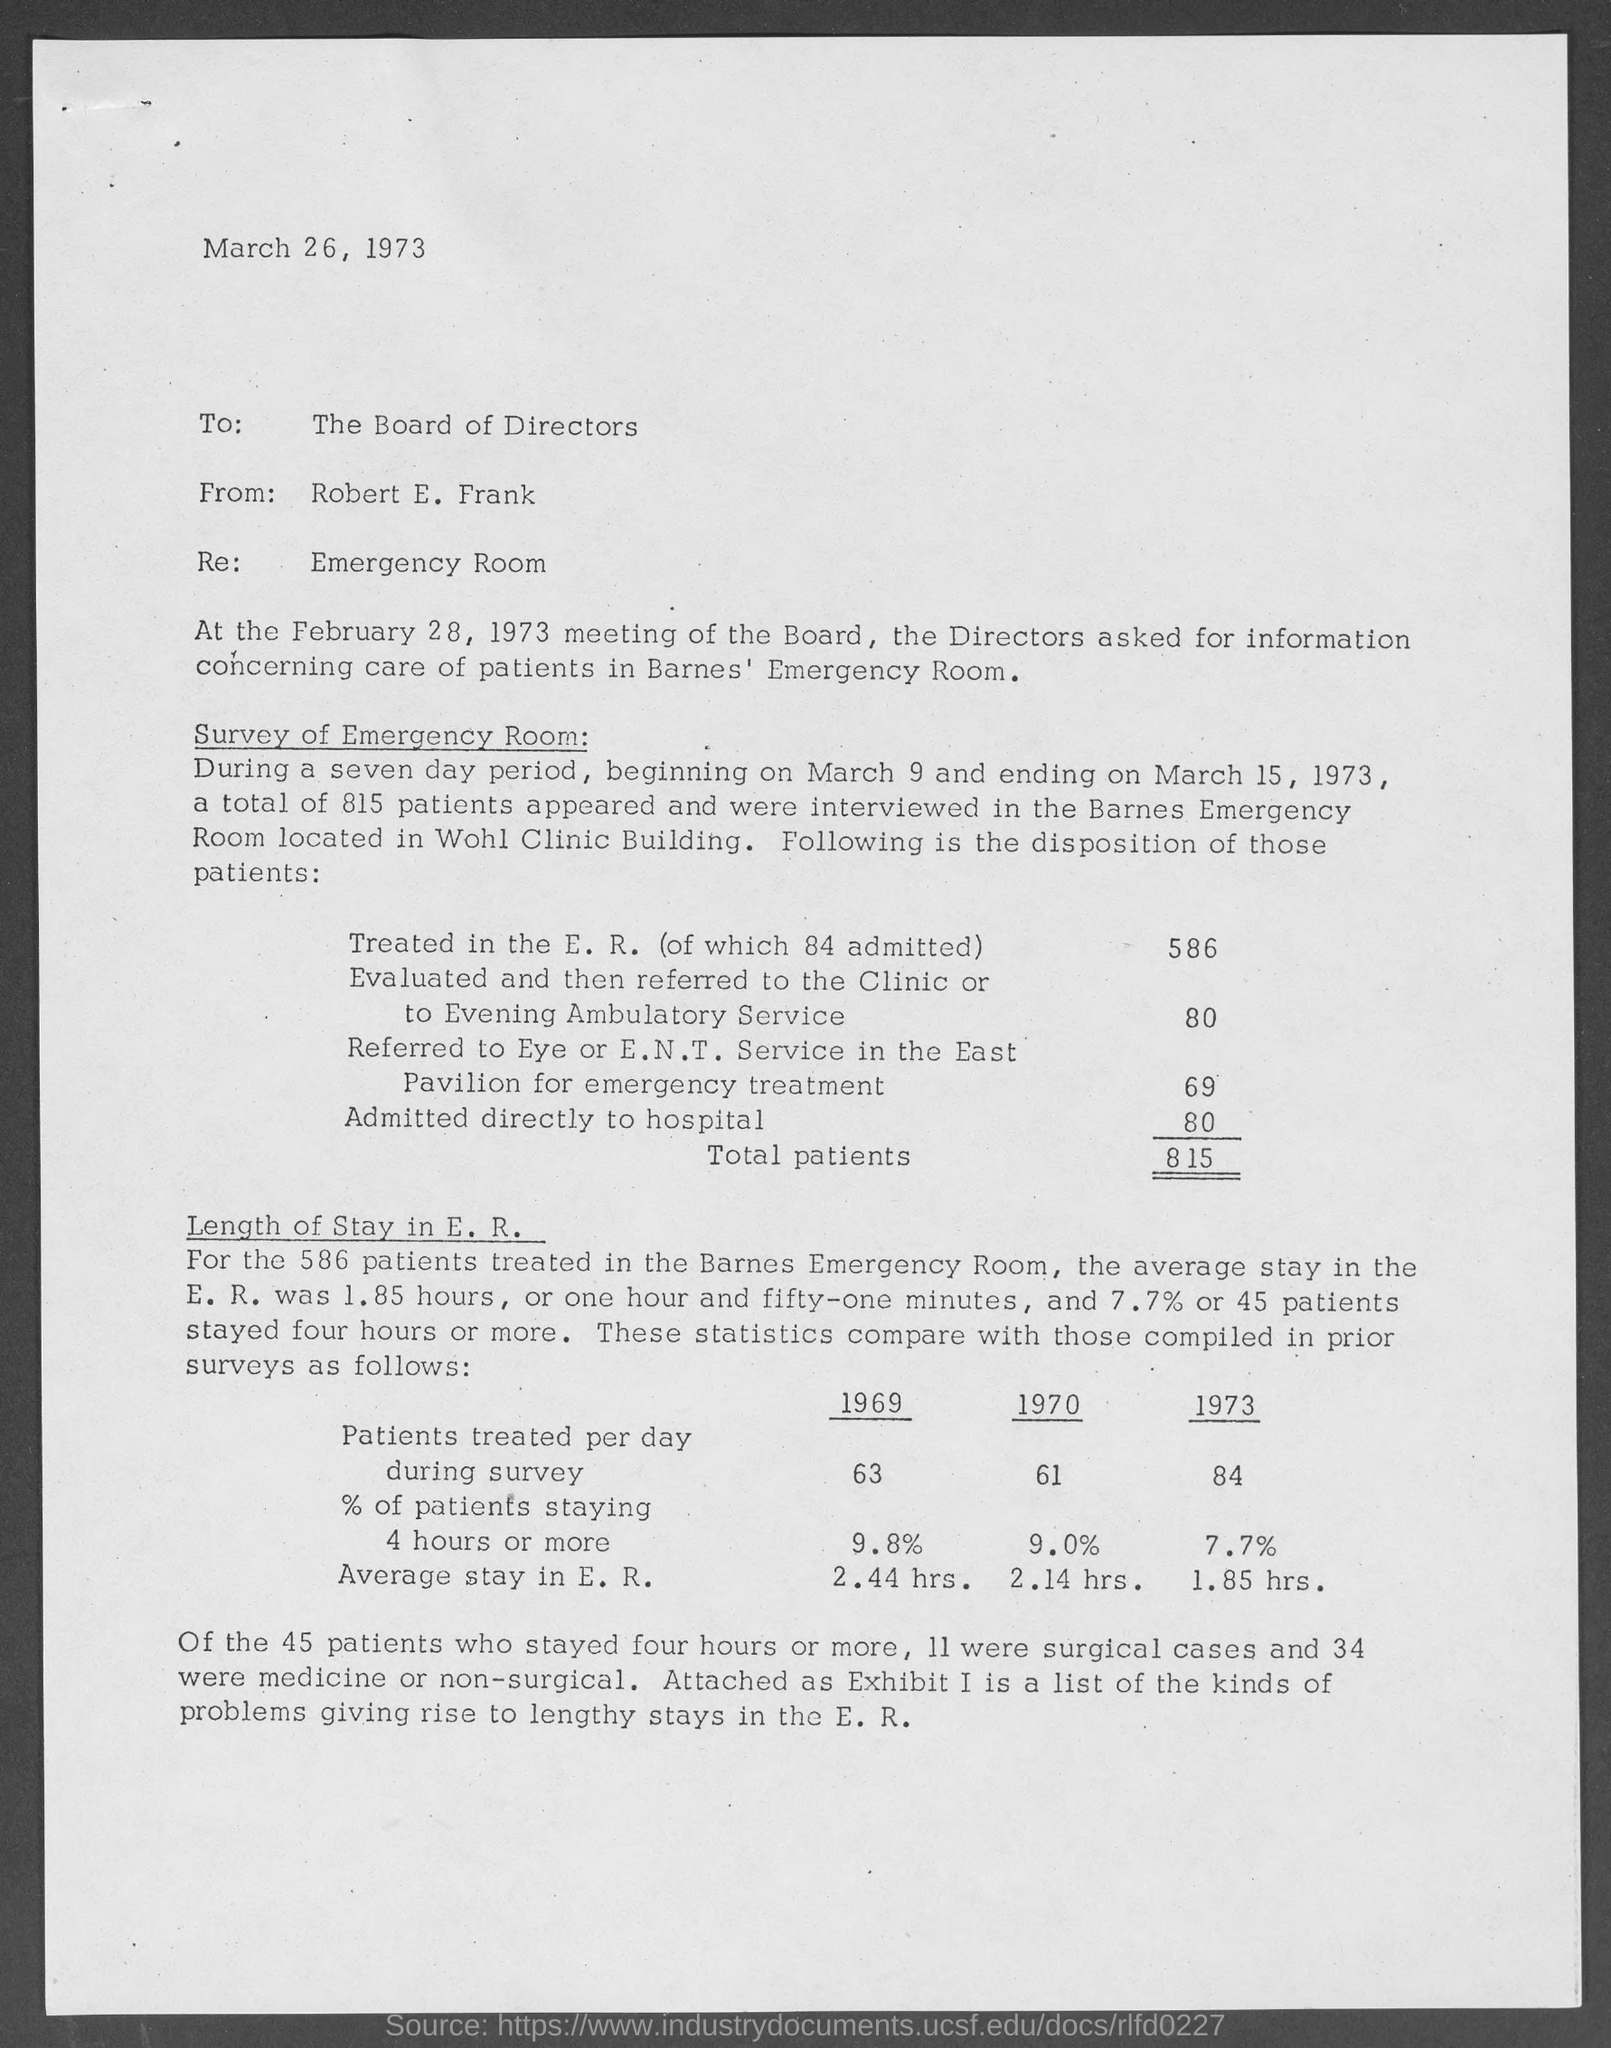The memo is dated on?
Your answer should be compact. MARCH 26, 1973. To whom is this memo for?
Offer a terse response. The board of directors. What is the total number of patients ?
Provide a short and direct response. 815. 